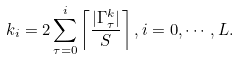<formula> <loc_0><loc_0><loc_500><loc_500>k _ { i } = 2 \sum _ { \tau = 0 } ^ { i } \left \lceil \frac { | { \Gamma } ^ { k } _ { \tau } | } { S } \right \rceil , i = 0 , \cdots , { L } .</formula> 